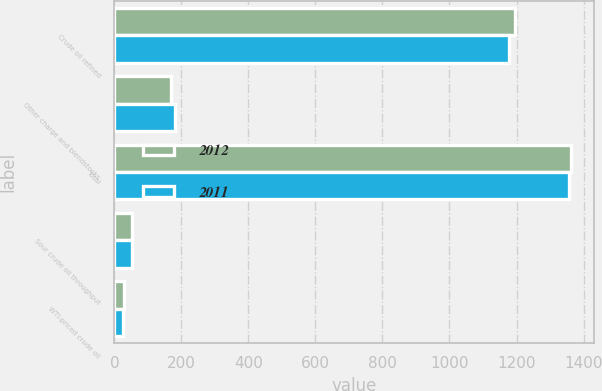Convert chart. <chart><loc_0><loc_0><loc_500><loc_500><stacked_bar_chart><ecel><fcel>Crude oil refined<fcel>Other charge and blendstocks<fcel>Total<fcel>Sour crude oil throughput<fcel>WTI-priced crude oil<nl><fcel>2012<fcel>1195<fcel>168<fcel>1363<fcel>53<fcel>28<nl><fcel>2011<fcel>1177<fcel>181<fcel>1358<fcel>52<fcel>27<nl></chart> 